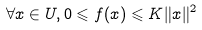Convert formula to latex. <formula><loc_0><loc_0><loc_500><loc_500>\forall x \in U , 0 \leqslant f ( x ) \leqslant K \| x \| ^ { 2 }</formula> 